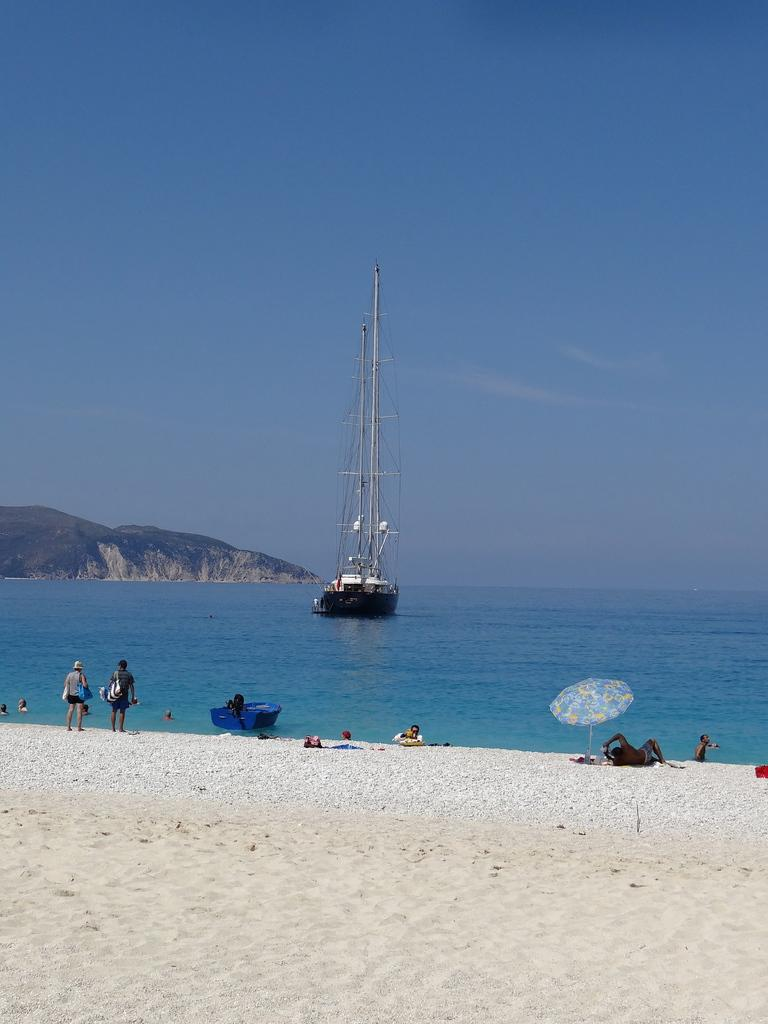How many people are in the image? There are people in the image, but the exact number is not specified. What are the positions of the people in the image? Two people are standing in the image. What type of terrain is visible in the image? There is sand and water visible in the image. What types of watercraft are present in the image? There is a ship and a boat in the image. What type of shelter is present in the image? There is an umbrella in the image. What type of geographical feature is visible in the image? There is a mountain in the image. What is visible in the background of the image? The sky is visible in the background of the image, with clouds present. What is the rate at which the duck is swimming in the image? There is no duck present in the image, so it is not possible to determine the rate at which it might be swimming. What type of needle is being used to sew the sail on the ship in the image? There is no needle present in the image, and the sail on the ship is not being sewn. 